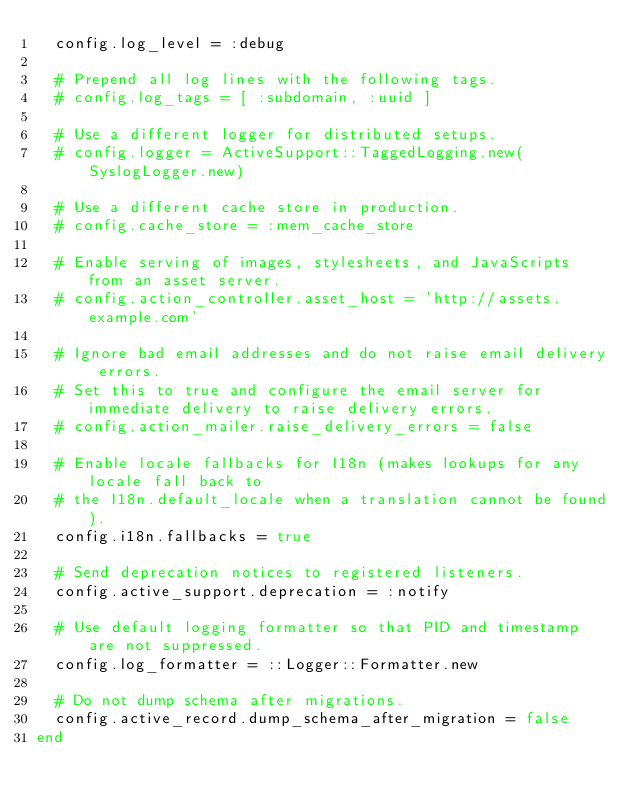Convert code to text. <code><loc_0><loc_0><loc_500><loc_500><_Ruby_>  config.log_level = :debug

  # Prepend all log lines with the following tags.
  # config.log_tags = [ :subdomain, :uuid ]

  # Use a different logger for distributed setups.
  # config.logger = ActiveSupport::TaggedLogging.new(SyslogLogger.new)

  # Use a different cache store in production.
  # config.cache_store = :mem_cache_store

  # Enable serving of images, stylesheets, and JavaScripts from an asset server.
  # config.action_controller.asset_host = 'http://assets.example.com'

  # Ignore bad email addresses and do not raise email delivery errors.
  # Set this to true and configure the email server for immediate delivery to raise delivery errors.
  # config.action_mailer.raise_delivery_errors = false

  # Enable locale fallbacks for I18n (makes lookups for any locale fall back to
  # the I18n.default_locale when a translation cannot be found).
  config.i18n.fallbacks = true

  # Send deprecation notices to registered listeners.
  config.active_support.deprecation = :notify

  # Use default logging formatter so that PID and timestamp are not suppressed.
  config.log_formatter = ::Logger::Formatter.new

  # Do not dump schema after migrations.
  config.active_record.dump_schema_after_migration = false
end
</code> 